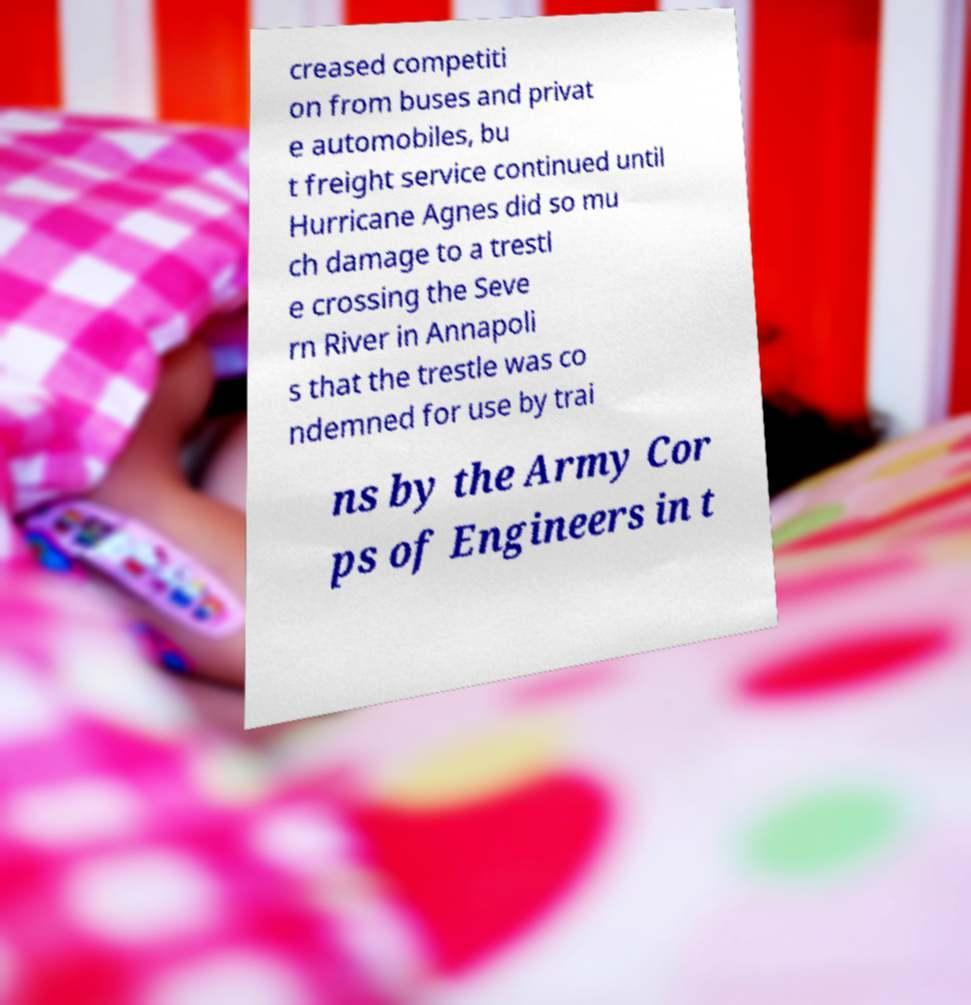Could you extract and type out the text from this image? creased competiti on from buses and privat e automobiles, bu t freight service continued until Hurricane Agnes did so mu ch damage to a trestl e crossing the Seve rn River in Annapoli s that the trestle was co ndemned for use by trai ns by the Army Cor ps of Engineers in t 